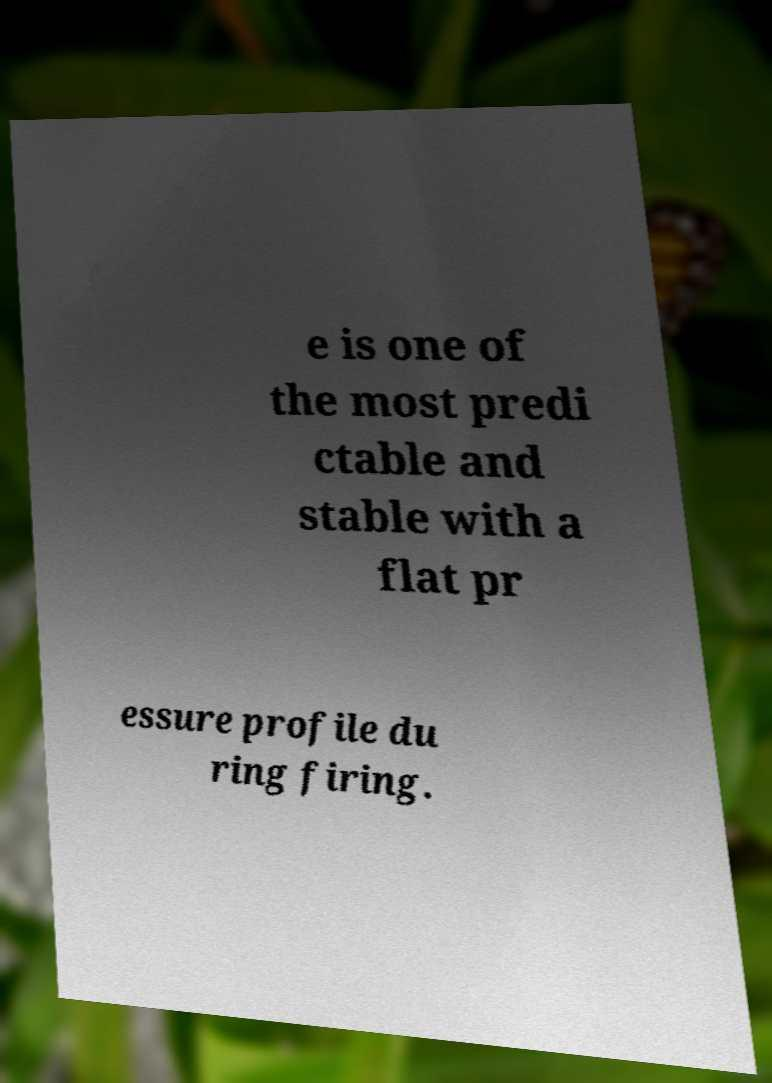For documentation purposes, I need the text within this image transcribed. Could you provide that? e is one of the most predi ctable and stable with a flat pr essure profile du ring firing. 